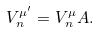<formula> <loc_0><loc_0><loc_500><loc_500>V _ { n } ^ { \mu ^ { \prime } } = V _ { n } ^ { \mu } A .</formula> 